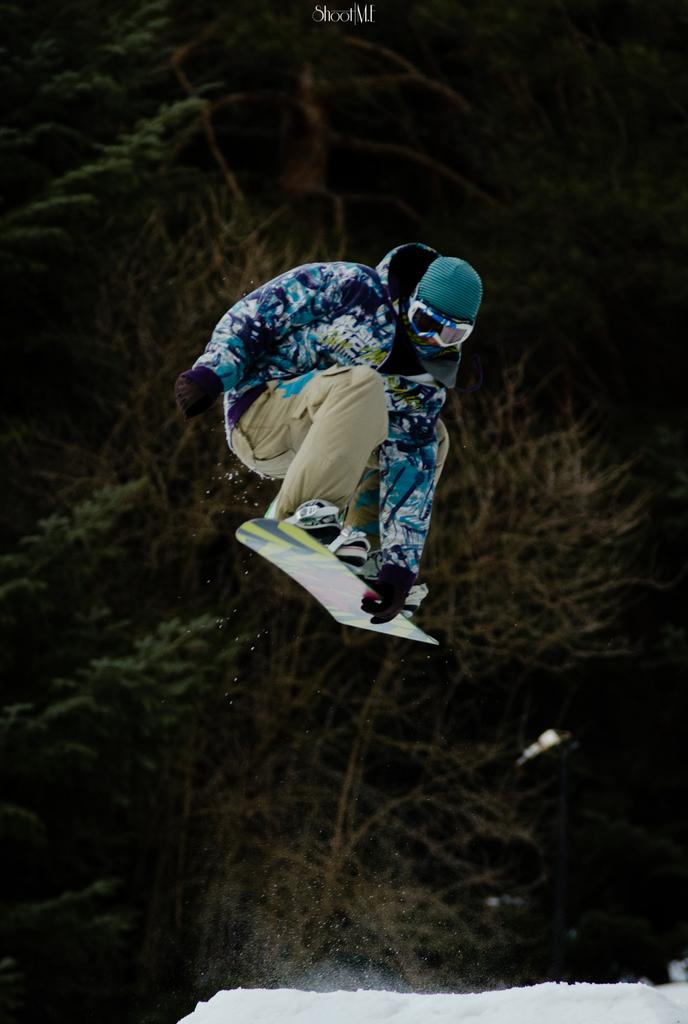Who is the person in the image? There is a man in the image. What is the man doing in the image? The man is riding a skiboard in the image. What is the man's position in the image? The man is in the air in the image. What can be seen in the background of the image? There are trees in the background of the image. What type of terrain is visible at the bottom of the image? There is snow visible at the bottom of the image. Reasoning: Let' Let's think step by step in order to produce the conversation. We start by identifying the main subject in the image, which is the man. Then, we describe what the man is doing, which is riding a skiboard. Next, we mention the man's position in the image, which is in the air. We then expand the conversation to include the background and terrain visible in the image. Absurd Question/Answer: What type of grass is growing on top of the skiboard in the image? There is no grass visible on the skiboard or anywhere else in the image. What type of grass is growing on top of the skiboard in the image? There is no grass visible on the skiboard or anywhere else in the image. 